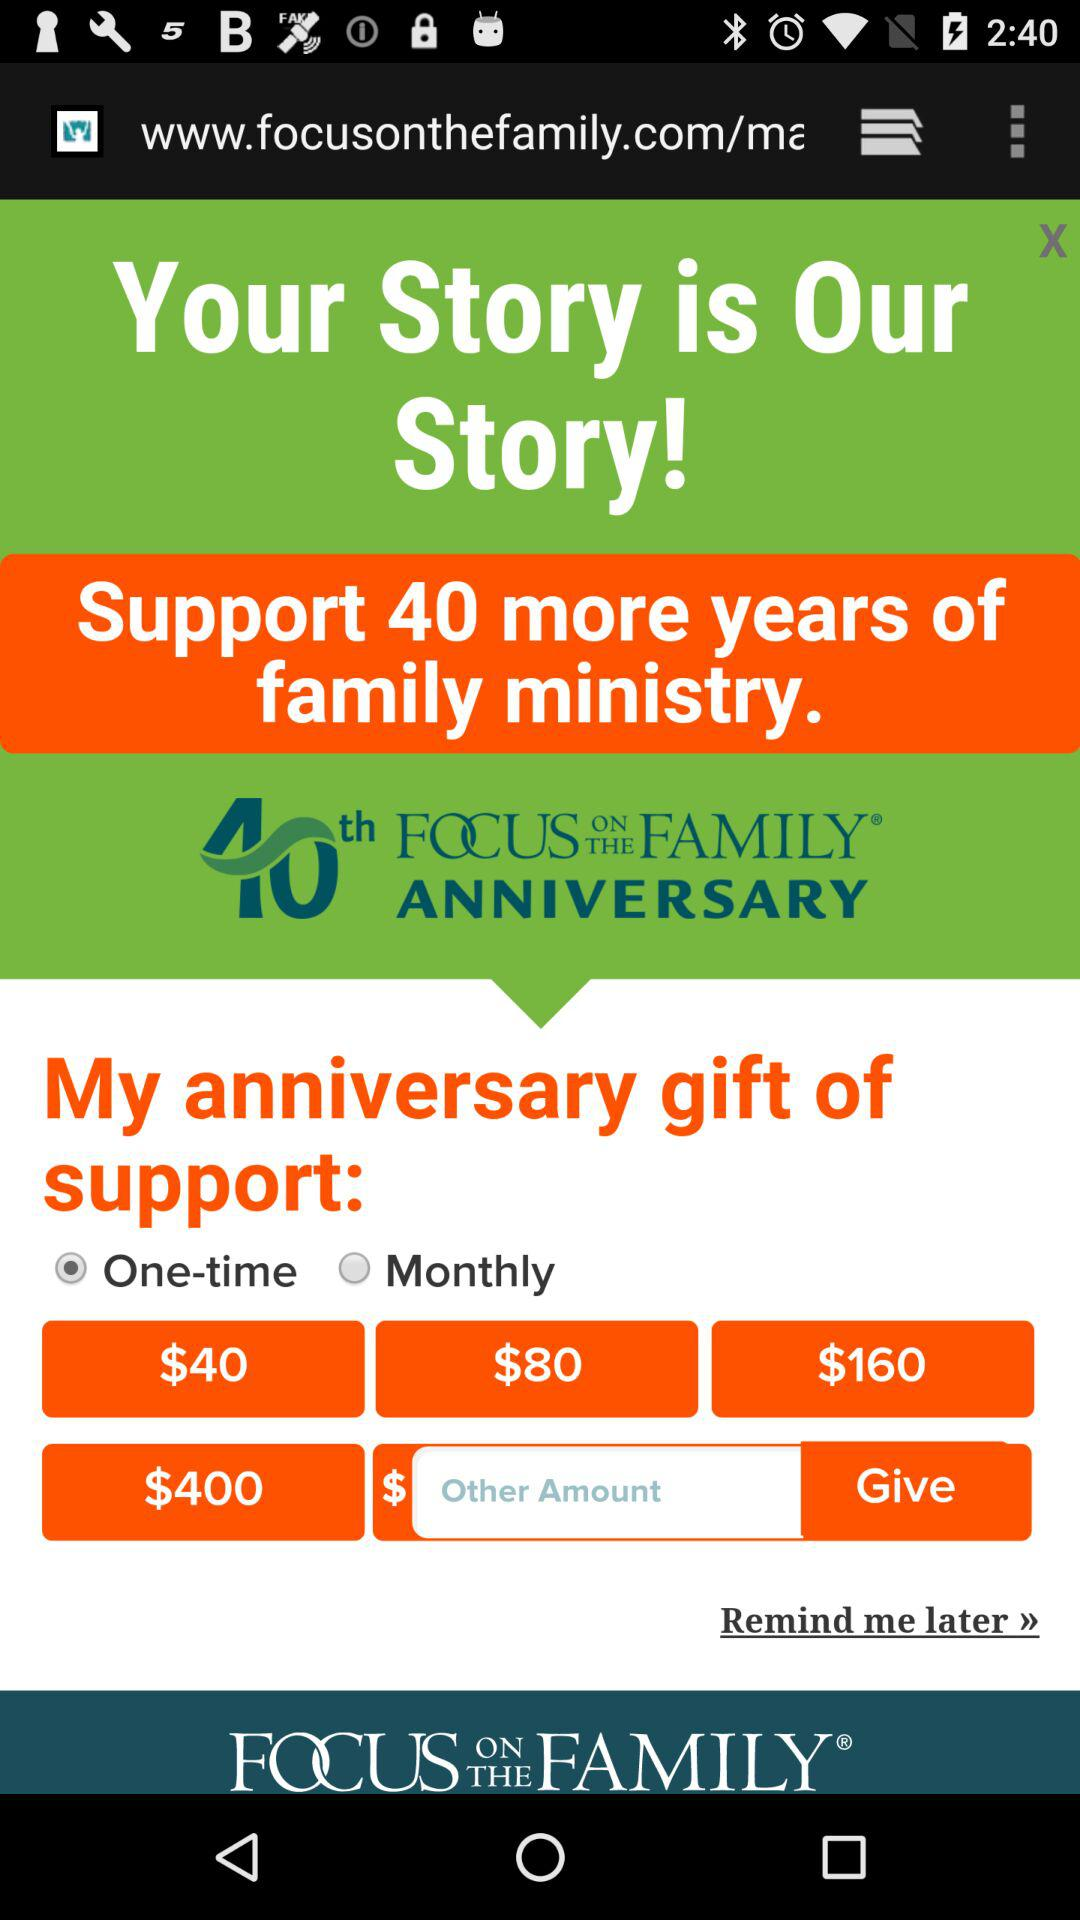What is the name of the organization? The name of the organisation is "FOCUS ON THE FAMILY". 